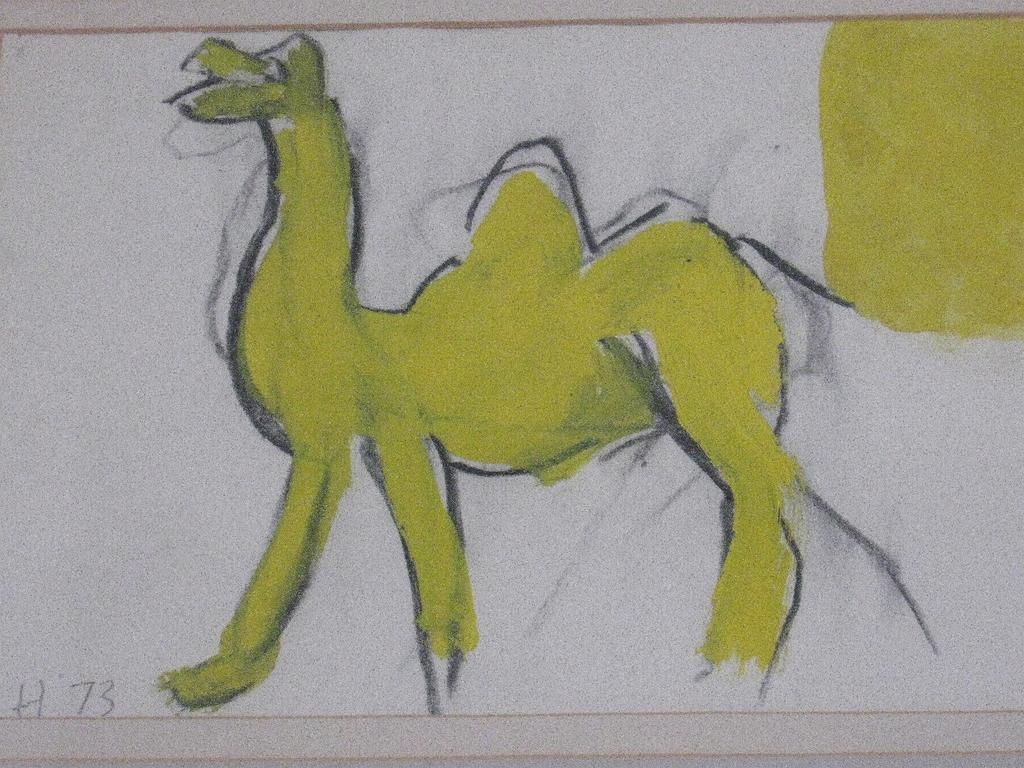What is depicted on the paper in the image? There is a sketch of an animal on the paper. What else is present on the paper besides the sketch? There is a letter and numbers on the paper. What type of fiction is the animal in the sketch involved in? The image does not depict any fiction or story involving the animal; it is simply a sketch on a piece of paper. 